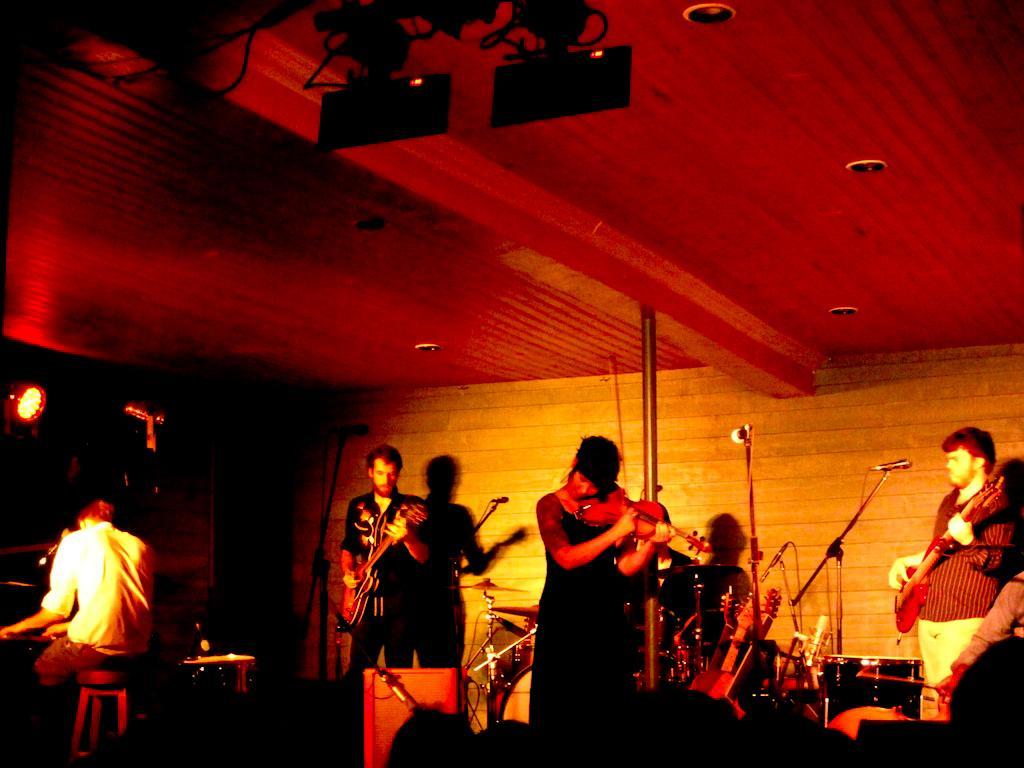Could you give a brief overview of what you see in this image? In the middle there is a woman she is playing violin. On the right there is a man he is playing guitar. On the left there is a man he is sitting and playing piano. On the left there is a man he is playing guitar. In the background there are many musical instruments ,mic and light. They are giving a stage performance. 